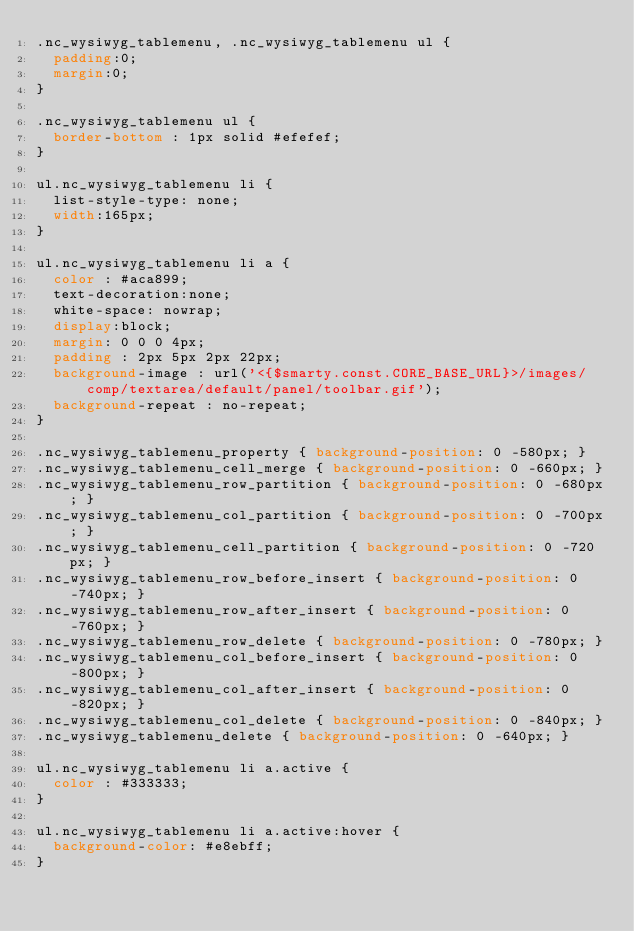Convert code to text. <code><loc_0><loc_0><loc_500><loc_500><_CSS_>.nc_wysiwyg_tablemenu, .nc_wysiwyg_tablemenu ul {
	padding:0;
	margin:0;
}

.nc_wysiwyg_tablemenu ul {
	border-bottom : 1px solid #efefef;	
}

ul.nc_wysiwyg_tablemenu li {
	list-style-type: none;
	width:165px;
}

ul.nc_wysiwyg_tablemenu li a {
	color : #aca899;
	text-decoration:none;
	white-space: nowrap;
	display:block;
	margin: 0 0 0 4px;
	padding : 2px 5px 2px 22px;
	background-image : url('<{$smarty.const.CORE_BASE_URL}>/images/comp/textarea/default/panel/toolbar.gif');
	background-repeat : no-repeat;
}

.nc_wysiwyg_tablemenu_property { background-position: 0 -580px; }
.nc_wysiwyg_tablemenu_cell_merge { background-position: 0 -660px; }
.nc_wysiwyg_tablemenu_row_partition { background-position: 0 -680px; }
.nc_wysiwyg_tablemenu_col_partition { background-position: 0 -700px; }
.nc_wysiwyg_tablemenu_cell_partition { background-position: 0 -720px; }
.nc_wysiwyg_tablemenu_row_before_insert { background-position: 0 -740px; }
.nc_wysiwyg_tablemenu_row_after_insert { background-position: 0 -760px; }
.nc_wysiwyg_tablemenu_row_delete { background-position: 0 -780px; }
.nc_wysiwyg_tablemenu_col_before_insert { background-position: 0 -800px; }
.nc_wysiwyg_tablemenu_col_after_insert { background-position: 0 -820px; }
.nc_wysiwyg_tablemenu_col_delete { background-position: 0 -840px; }
.nc_wysiwyg_tablemenu_delete { background-position: 0 -640px; }

ul.nc_wysiwyg_tablemenu li a.active {
	color : #333333;
}

ul.nc_wysiwyg_tablemenu li a.active:hover {
	background-color: #e8ebff;
}</code> 